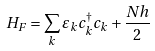<formula> <loc_0><loc_0><loc_500><loc_500>H _ { F } = \sum _ { k } \varepsilon _ { k } c _ { k } ^ { \dag } c _ { k } + \frac { N h } { 2 }</formula> 